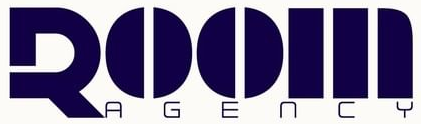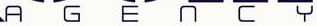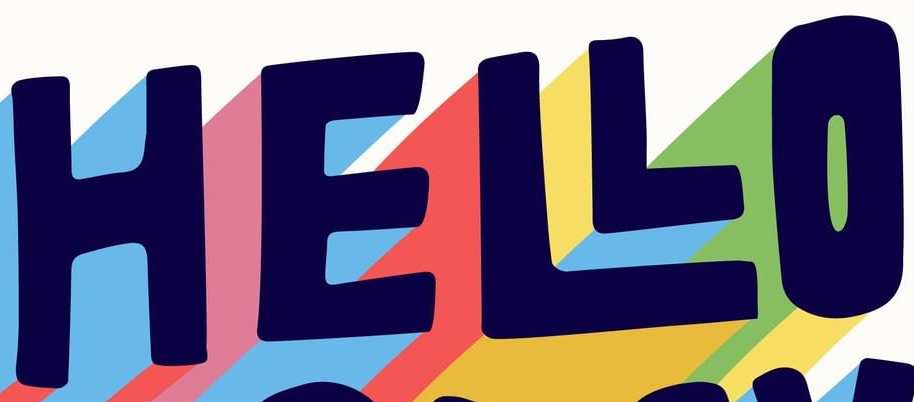What words can you see in these images in sequence, separated by a semicolon? ROOM; AGENCY; HELLO 